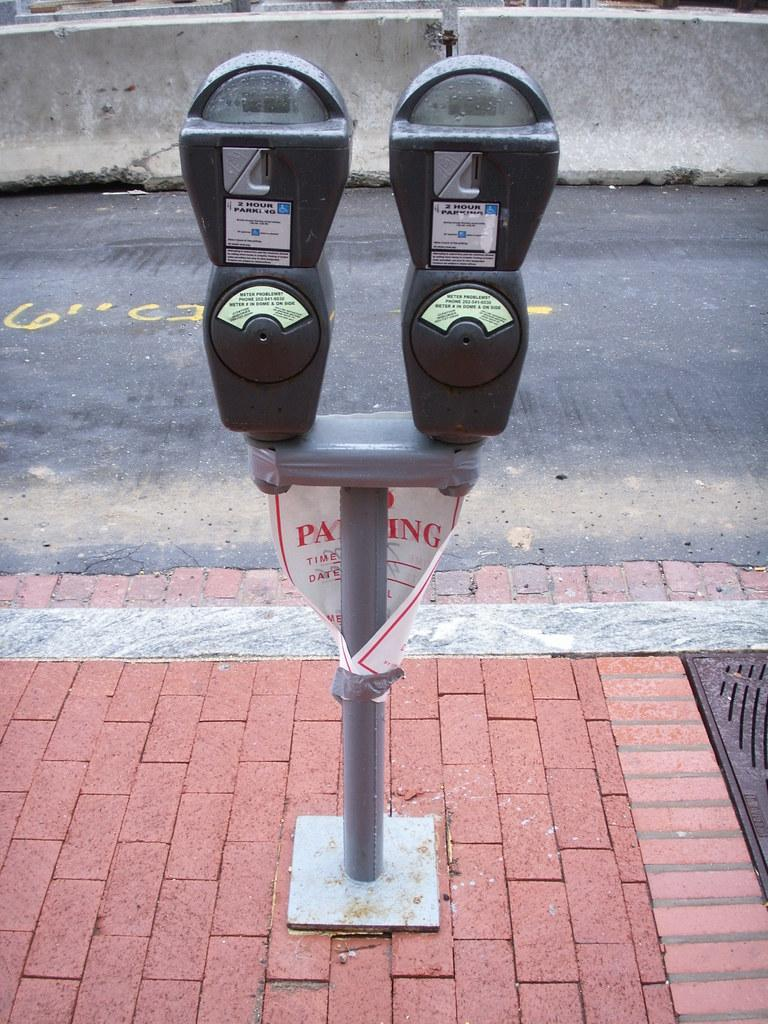What is on the stand in the image? There is a poster and two objects on the stand in the image. What can be seen in the background of the image? There is a road and a wall visible in the background of the image. What type of skin condition is visible on the poster in the image? There is no skin condition visible on the poster in the image, as the poster is not focused on any medical or health-related topic. 